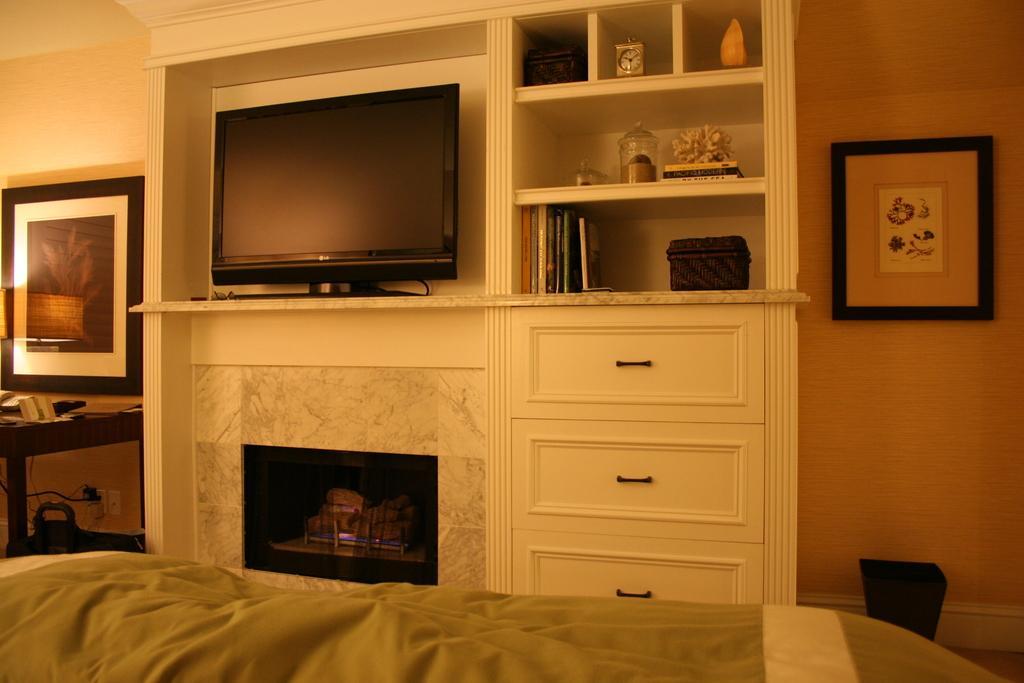Can you describe this image briefly? This image is clicked inside a room. There are photo frames on the left side and right side. In the middle there is a TV. There are cupboard. In that cupboard there is a clock, books, boxes. There is a bed at the bottom. 